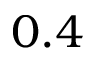Convert formula to latex. <formula><loc_0><loc_0><loc_500><loc_500>0 . 4</formula> 